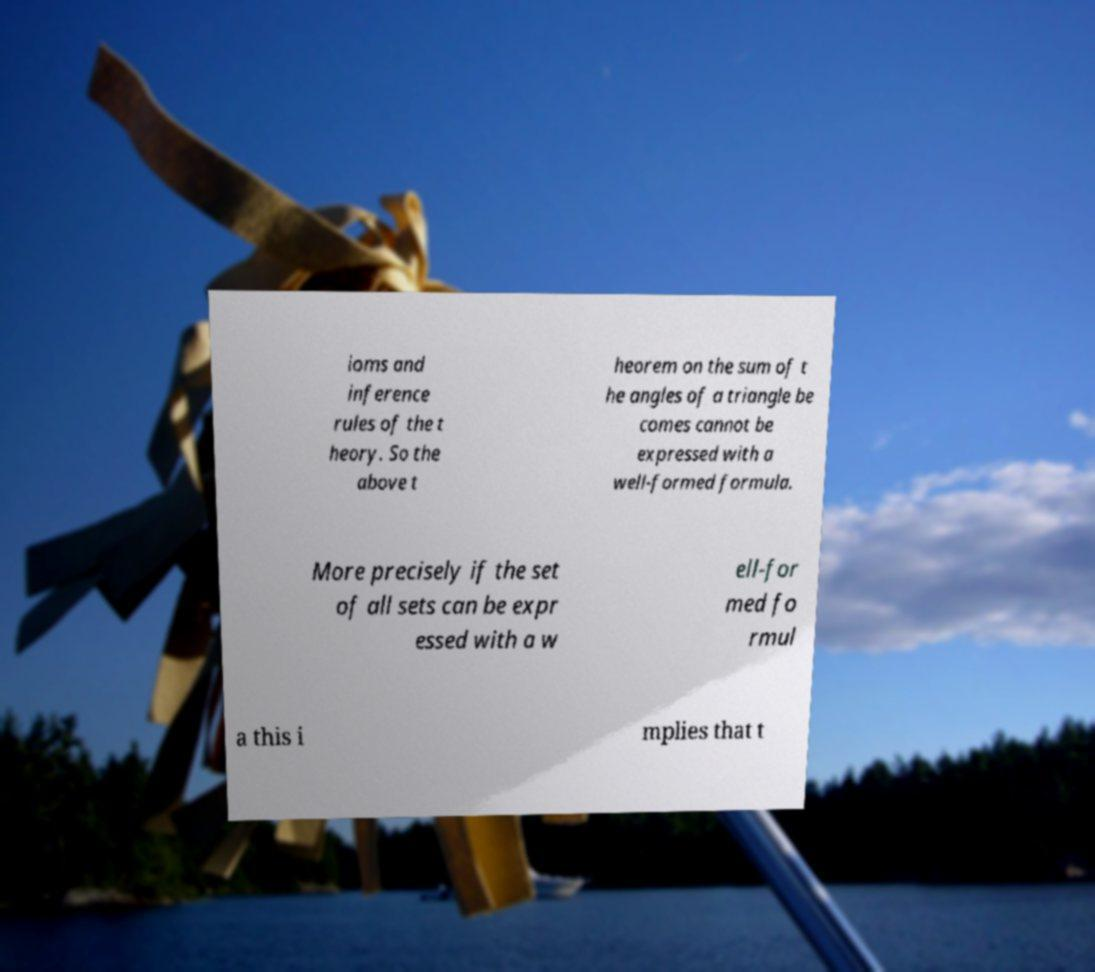Could you assist in decoding the text presented in this image and type it out clearly? ioms and inference rules of the t heory. So the above t heorem on the sum of t he angles of a triangle be comes cannot be expressed with a well-formed formula. More precisely if the set of all sets can be expr essed with a w ell-for med fo rmul a this i mplies that t 